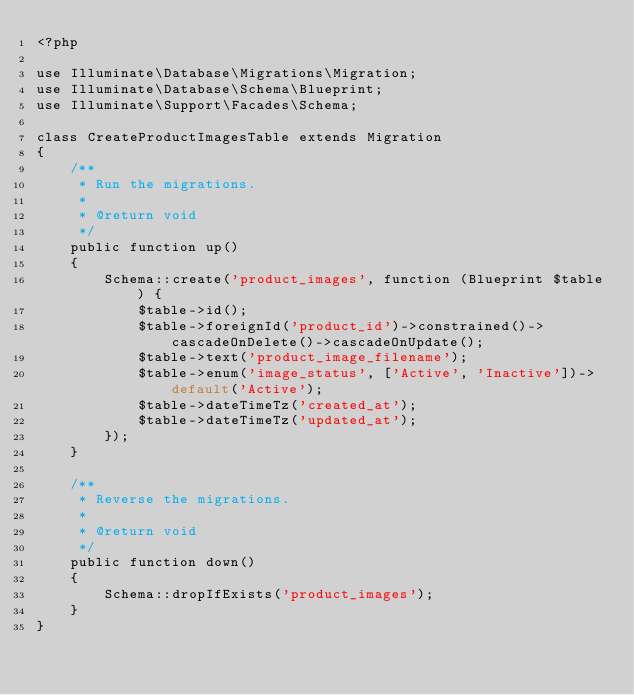Convert code to text. <code><loc_0><loc_0><loc_500><loc_500><_PHP_><?php

use Illuminate\Database\Migrations\Migration;
use Illuminate\Database\Schema\Blueprint;
use Illuminate\Support\Facades\Schema;

class CreateProductImagesTable extends Migration
{
    /**
     * Run the migrations.
     *
     * @return void
     */
    public function up()
    {
        Schema::create('product_images', function (Blueprint $table) {
            $table->id();
            $table->foreignId('product_id')->constrained()->cascadeOnDelete()->cascadeOnUpdate();
            $table->text('product_image_filename');
            $table->enum('image_status', ['Active', 'Inactive'])->default('Active');
            $table->dateTimeTz('created_at');
            $table->dateTimeTz('updated_at');
        });
    }

    /**
     * Reverse the migrations.
     *
     * @return void
     */
    public function down()
    {
        Schema::dropIfExists('product_images');
    }
}
</code> 